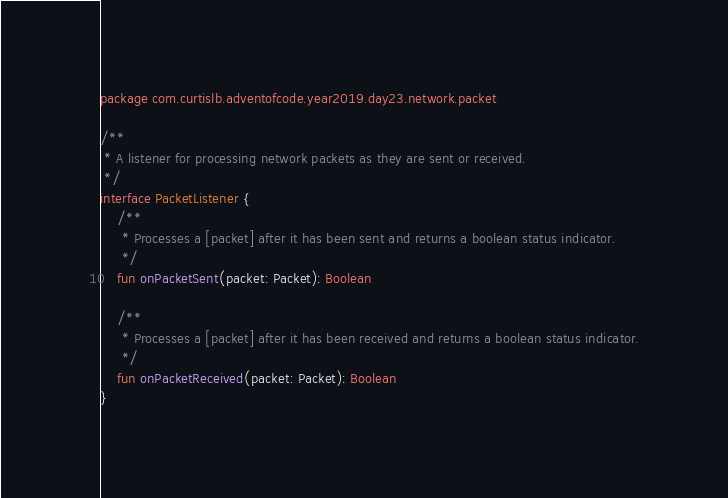<code> <loc_0><loc_0><loc_500><loc_500><_Kotlin_>package com.curtislb.adventofcode.year2019.day23.network.packet

/**
 * A listener for processing network packets as they are sent or received.
 */
interface PacketListener {
    /**
     * Processes a [packet] after it has been sent and returns a boolean status indicator.
     */
    fun onPacketSent(packet: Packet): Boolean

    /**
     * Processes a [packet] after it has been received and returns a boolean status indicator.
     */
    fun onPacketReceived(packet: Packet): Boolean
}
</code> 